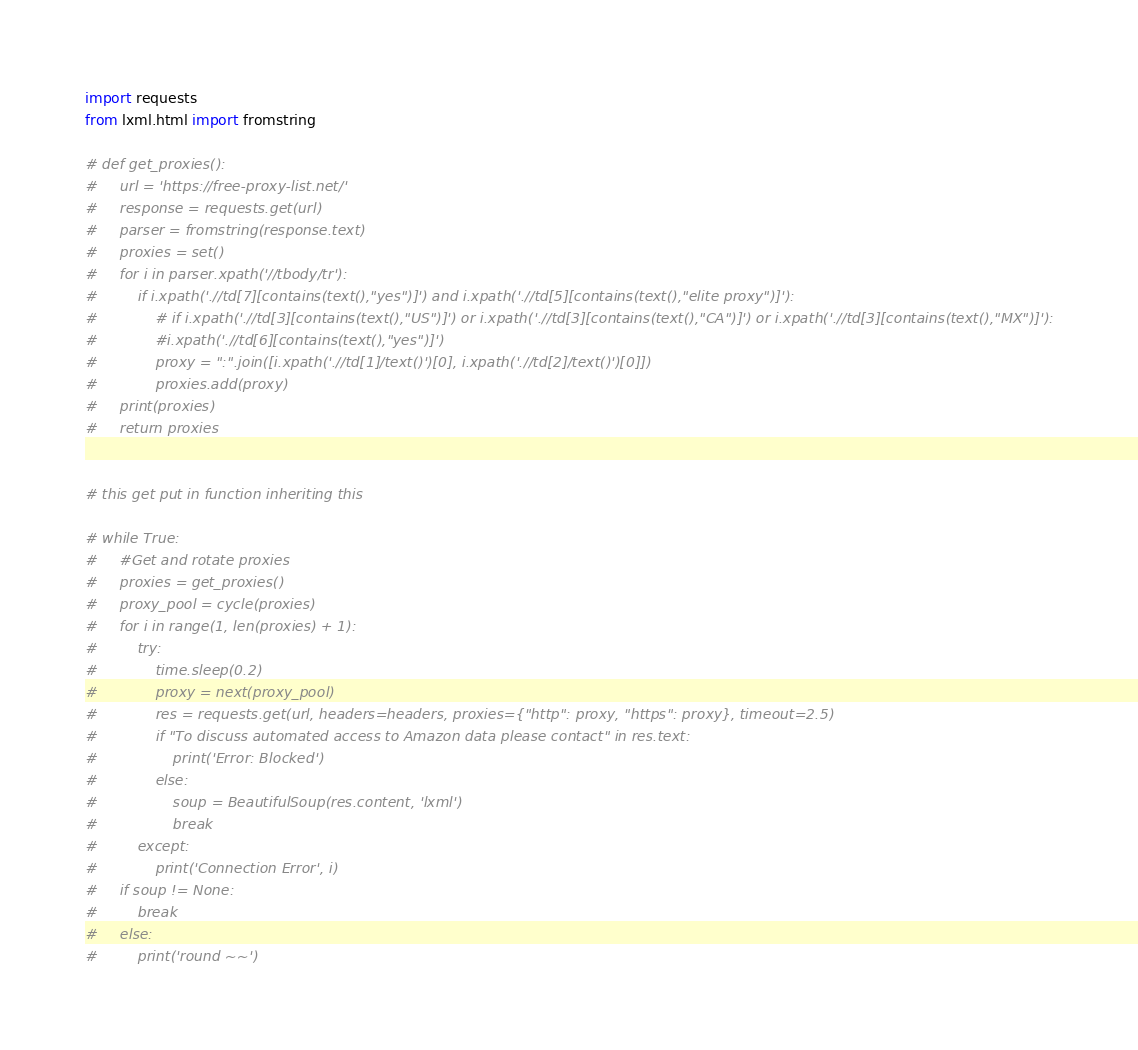Convert code to text. <code><loc_0><loc_0><loc_500><loc_500><_Python_>import requests
from lxml.html import fromstring

# def get_proxies():
#     url = 'https://free-proxy-list.net/'
#     response = requests.get(url)
#     parser = fromstring(response.text)
#     proxies = set()
#     for i in parser.xpath('//tbody/tr'):
#         if i.xpath('.//td[7][contains(text(),"yes")]') and i.xpath('.//td[5][contains(text(),"elite proxy")]'):
#             # if i.xpath('.//td[3][contains(text(),"US")]') or i.xpath('.//td[3][contains(text(),"CA")]') or i.xpath('.//td[3][contains(text(),"MX")]'):
#             #i.xpath('.//td[6][contains(text(),"yes")]')
#             proxy = ":".join([i.xpath('.//td[1]/text()')[0], i.xpath('.//td[2]/text()')[0]])
#             proxies.add(proxy)
#     print(proxies)
#     return proxies


# this get put in function inheriting this

# while True:
#     #Get and rotate proxies
#     proxies = get_proxies()
#     proxy_pool = cycle(proxies)
#     for i in range(1, len(proxies) + 1):
#         try:
#             time.sleep(0.2)
#             proxy = next(proxy_pool)
#             res = requests.get(url, headers=headers, proxies={"http": proxy, "https": proxy}, timeout=2.5)
#             if "To discuss automated access to Amazon data please contact" in res.text:
#                 print('Error: Blocked')
#             else:
#                 soup = BeautifulSoup(res.content, 'lxml')
#                 break
#         except:
#             print('Connection Error', i)
#     if soup != None:
#         break
#     else:
#         print('round ~~')
</code> 